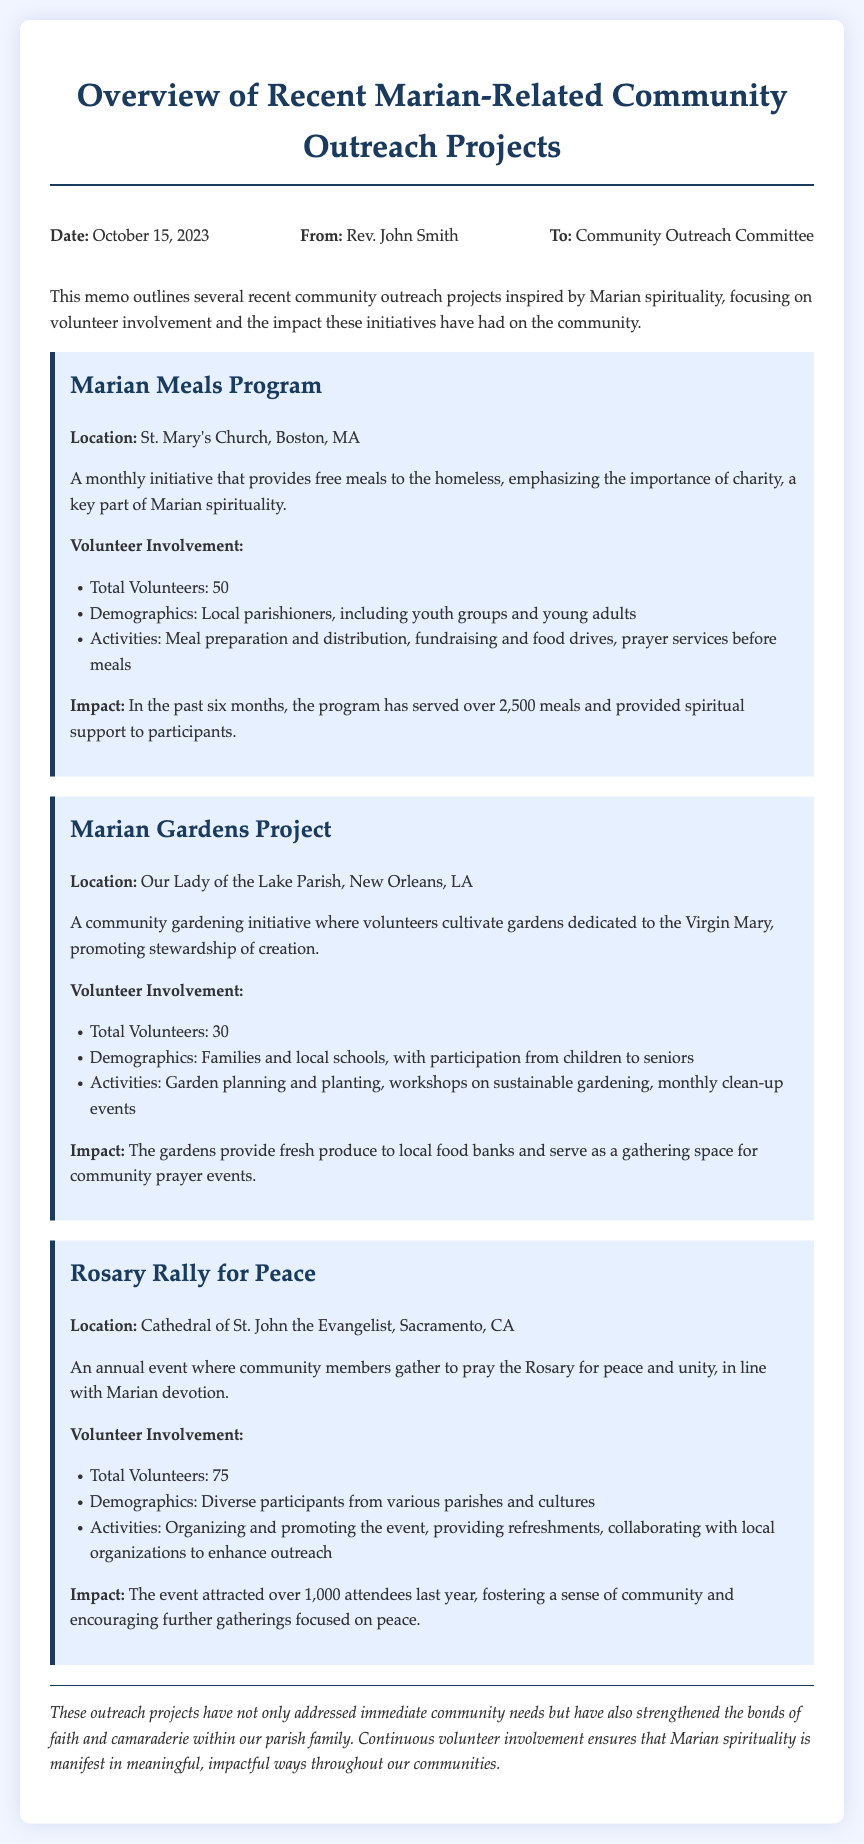what is the date of the memo? The date of the memo is provided in the header section.
Answer: October 15, 2023 who is the author of the memo? The author of the memo is mentioned at the beginning of the document.
Answer: Rev. John Smith how many volunteers participated in the Marian Meals Program? The number of volunteers is listed under the "Volunteer Involvement" section of the Marian Meals Program.
Answer: 50 what is the location of the Rosary Rally for Peace? The location is specifically mentioned in the section describing the event.
Answer: Cathedral of St. John the Evangelist, Sacramento, CA what is the impact of the Marian Gardens Project? The impact is detailed in the respective project section.
Answer: Provide fresh produce to local food banks and serve as a gathering space for community prayer events how many attendees were at last year's Rosary Rally for Peace? The number of attendees is stated in the impact section of the Rosary Rally for Peace.
Answer: Over 1,000 which demographic primarily engaged in the Marian Gardens Project? The demographics of volunteers are outlined in the respective project section.
Answer: Families and local schools what is a key aspect of Marian spirituality emphasized in these projects? The key aspect is related to the themes highlighted in the projects.
Answer: Charity 